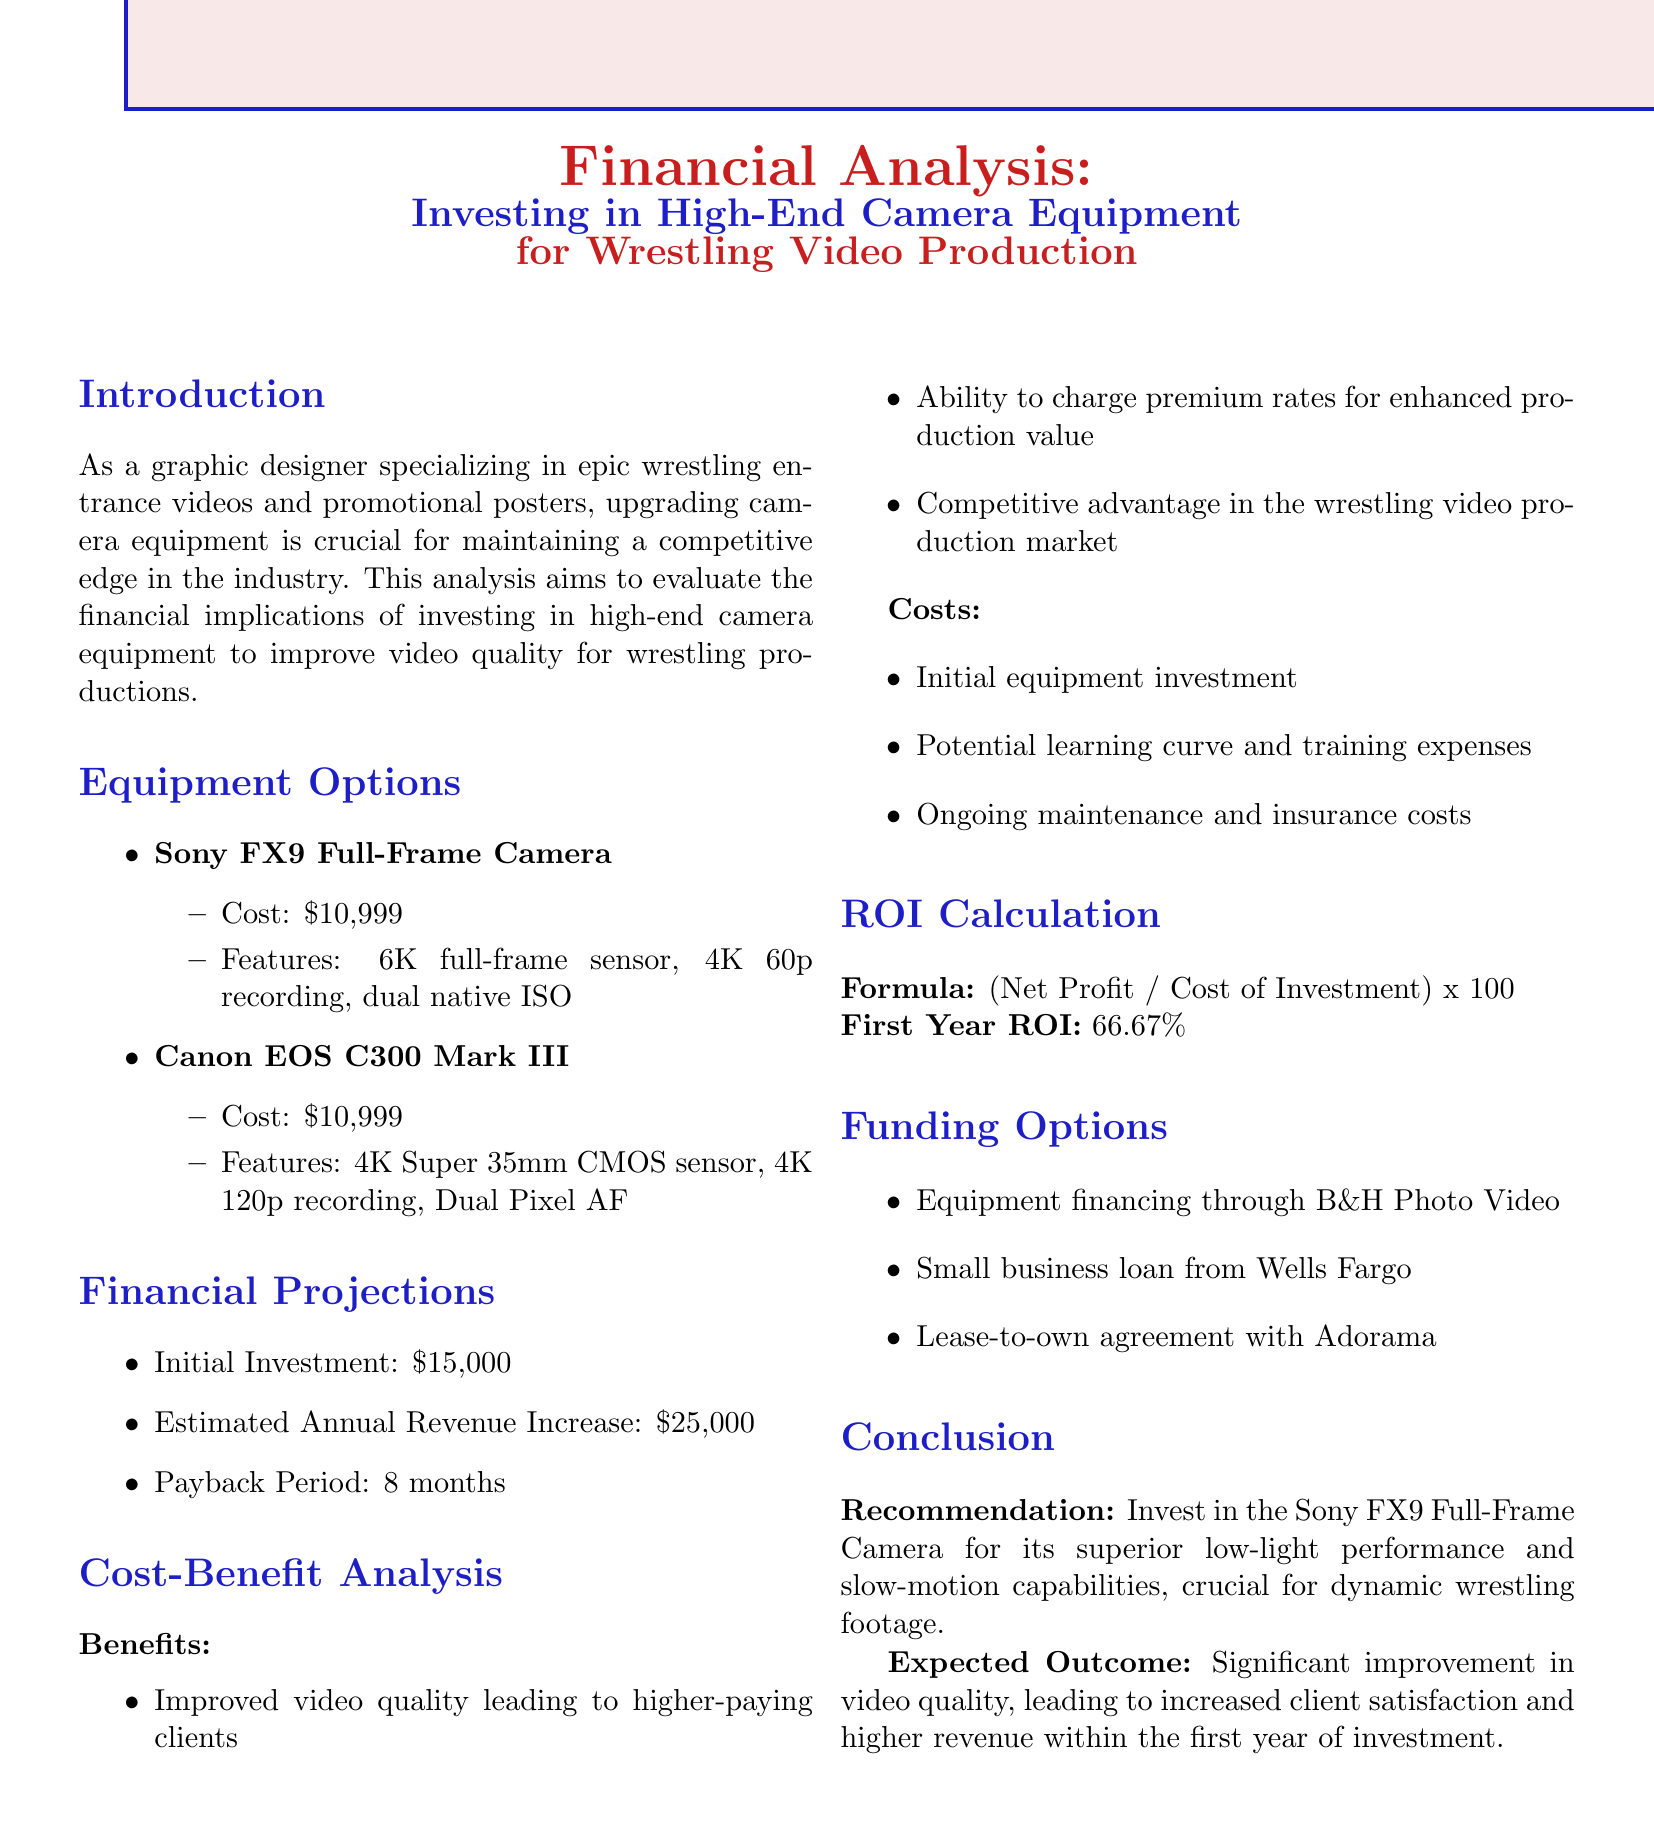what is the cost of the Sony FX9 Full-Frame Camera? The cost of the Sony FX9 Full-Frame Camera is mentioned in the equipment options section of the document.
Answer: $10,999 what are the key features of the Canon EOS C300 Mark III? The features of the Canon EOS C300 Mark III are detailed in the equipment options section.
Answer: 4K Super 35mm CMOS sensor, 4K 120p recording, Dual Pixel AF what is the estimated annual revenue increase from the investment? The document provides a projection for the annual revenue increase based on the investment in high-end camera equipment.
Answer: $25,000 how long is the payback period for the initial investment? The payback period is specifically stated in the financial projections section.
Answer: 8 months what is the first year return on investment? The first year ROI is calculated and clearly stated in the ROI calculation section of the document.
Answer: 66.67% what are two benefits of investing in high-end camera equipment? The benefits are listed in the cost-benefit analysis section, providing reasons for the investment.
Answer: Improved video quality, Ability to charge premium rates what are two potential costs associated with the investment? The costs are outlined in the cost-benefit analysis section, detailing possible financial implications.
Answer: Initial equipment investment, Ongoing maintenance and insurance costs what is the recommendation for equipment investment? The document concludes with a recommendation based on the analysis performed.
Answer: Invest in the Sony FX9 Full-Frame Camera what funding option is suggested in the document? The funding options section lists various methods available for financing the camera equipment.
Answer: Equipment financing through B&H Photo Video 